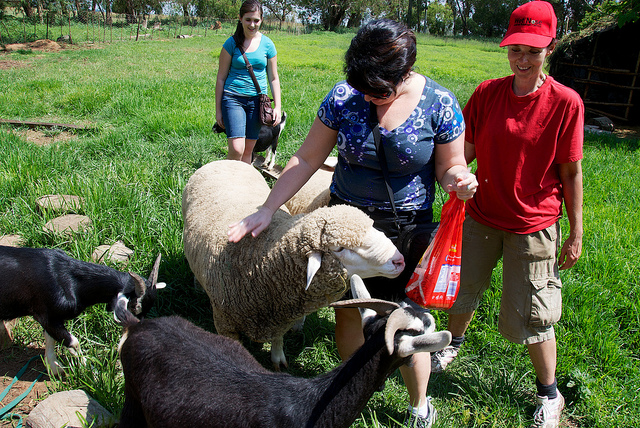Can you explain why the plastic bag might be out of place in this setting? In a typical farm or pasture setting, one would expect to see farming tools, feed, or natural items rather than a plastic bag. A plastic bag is usually associated with shopping or urban environments. Its presence might indicate an item brought from outside the farm, and it could potentially be litter. Ensuring such items are kept away from animals is crucial to prevent any health hazards, as they might ingest the plastic. 